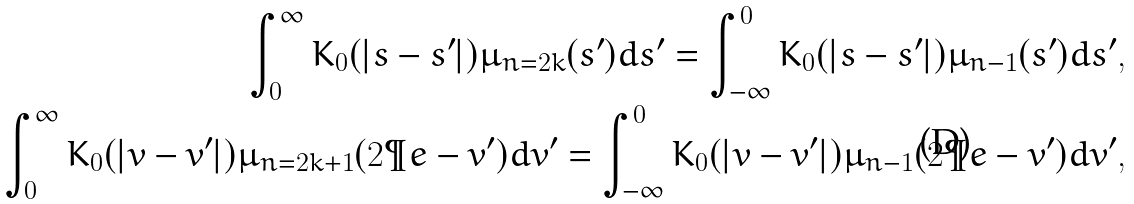Convert formula to latex. <formula><loc_0><loc_0><loc_500><loc_500>\int _ { 0 } ^ { \infty } K _ { 0 } ( | s - s ^ { \prime } | ) \mu _ { n = 2 k } ( s ^ { \prime } ) d s ^ { \prime } = \int _ { - \infty } ^ { 0 } K _ { 0 } ( | s - s ^ { \prime } | ) \mu _ { n - 1 } ( s ^ { \prime } ) d s ^ { \prime } , \\ \int _ { 0 } ^ { \infty } K _ { 0 } ( | v - v ^ { \prime } | ) \mu _ { n = 2 k + 1 } ( 2 \P e - v ^ { \prime } ) d v ^ { \prime } = \int _ { - \infty } ^ { 0 } K _ { 0 } ( | v - v ^ { \prime } | ) \mu _ { n - 1 } ( 2 \P e - v ^ { \prime } ) d v ^ { \prime } ,</formula> 